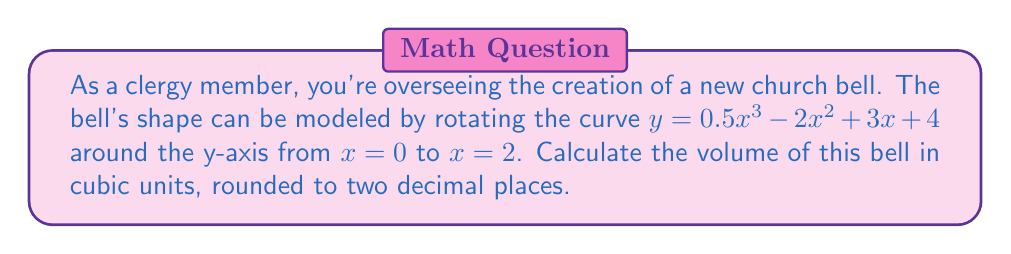Give your solution to this math problem. To find the volume of the bell, we need to use the formula for the volume of a solid of revolution:

$$V = \pi \int_a^b [f(x)]^2 dx$$

Where $f(x) = 0.5x^3 - 2x^2 + 3x + 4$, $a = 0$, and $b = 2$.

Step 1: Square the function $f(x)$
$[f(x)]^2 = (0.5x^3 - 2x^2 + 3x + 4)^2$
$= 0.25x^6 - 2x^5 + 3.5x^4 - 4x^3 + 9x^2 + 24x + 16$

Step 2: Integrate $[f(x)]^2$ from 0 to 2
$$\int_0^2 (0.25x^6 - 2x^5 + 3.5x^4 - 4x^3 + 9x^2 + 24x + 16) dx$$
$$= [\frac{0.25x^7}{7} - \frac{2x^6}{6} + \frac{3.5x^5}{5} - x^4 + 3x^3 + 12x^2 + 16x]_0^2$$

Step 3: Evaluate the integral
$$= (\frac{0.25 \cdot 2^7}{7} - \frac{2 \cdot 2^6}{6} + \frac{3.5 \cdot 2^5}{5} - 2^4 + 3 \cdot 2^3 + 12 \cdot 2^2 + 16 \cdot 2) - (0)$$
$$= (9.14 - 21.33 + 44.8 - 16 + 24 + 48 + 32) - 0$$
$$= 120.61$$

Step 4: Multiply by $\pi$
$$V = \pi \cdot 120.61 = 378.83$$

Step 5: Round to two decimal places
$$V \approx 378.83 \text{ cubic units}$$
Answer: 378.83 cubic units 